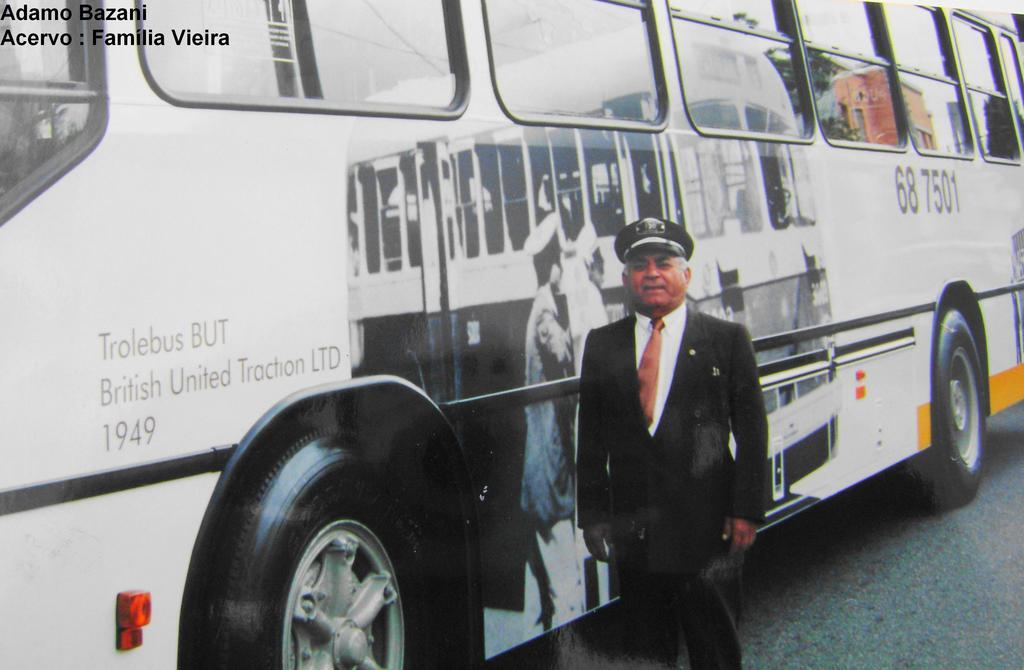<image>
Present a compact description of the photo's key features. A uniformed man stands by a bus labeled Trolebus BUT and dated 1949. 